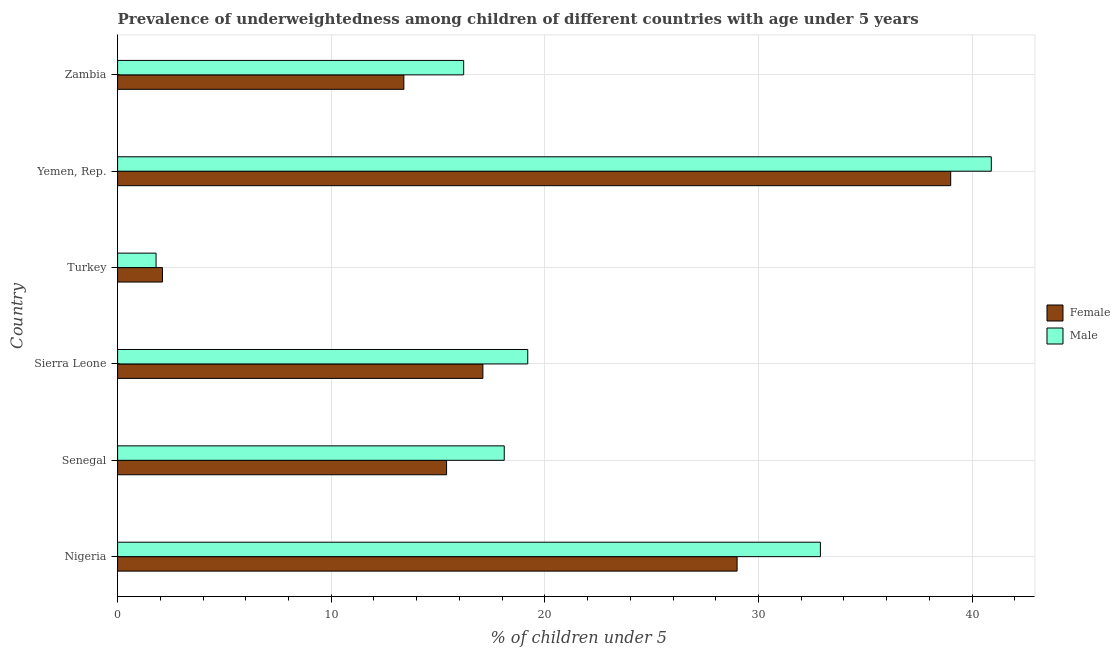Are the number of bars per tick equal to the number of legend labels?
Your answer should be very brief. Yes. How many bars are there on the 6th tick from the bottom?
Make the answer very short. 2. What is the label of the 6th group of bars from the top?
Give a very brief answer. Nigeria. In how many cases, is the number of bars for a given country not equal to the number of legend labels?
Keep it short and to the point. 0. Across all countries, what is the maximum percentage of underweighted female children?
Provide a short and direct response. 39. Across all countries, what is the minimum percentage of underweighted female children?
Your response must be concise. 2.1. In which country was the percentage of underweighted male children maximum?
Offer a terse response. Yemen, Rep. In which country was the percentage of underweighted female children minimum?
Provide a succinct answer. Turkey. What is the total percentage of underweighted female children in the graph?
Make the answer very short. 116. What is the difference between the percentage of underweighted female children in Sierra Leone and that in Zambia?
Your answer should be compact. 3.7. What is the difference between the percentage of underweighted male children in Zambia and the percentage of underweighted female children in Senegal?
Ensure brevity in your answer.  0.8. What is the average percentage of underweighted female children per country?
Keep it short and to the point. 19.33. What is the ratio of the percentage of underweighted female children in Turkey to that in Yemen, Rep.?
Offer a terse response. 0.05. Is the percentage of underweighted female children in Nigeria less than that in Yemen, Rep.?
Provide a succinct answer. Yes. Is the difference between the percentage of underweighted male children in Yemen, Rep. and Zambia greater than the difference between the percentage of underweighted female children in Yemen, Rep. and Zambia?
Offer a very short reply. No. What is the difference between the highest and the second highest percentage of underweighted male children?
Your response must be concise. 8. What is the difference between the highest and the lowest percentage of underweighted female children?
Provide a succinct answer. 36.9. Is the sum of the percentage of underweighted female children in Senegal and Turkey greater than the maximum percentage of underweighted male children across all countries?
Your answer should be compact. No. What does the 2nd bar from the top in Zambia represents?
Give a very brief answer. Female. What does the 2nd bar from the bottom in Senegal represents?
Your answer should be very brief. Male. How many countries are there in the graph?
Your answer should be very brief. 6. Are the values on the major ticks of X-axis written in scientific E-notation?
Provide a succinct answer. No. Does the graph contain grids?
Your answer should be very brief. Yes. Where does the legend appear in the graph?
Give a very brief answer. Center right. How many legend labels are there?
Offer a terse response. 2. How are the legend labels stacked?
Offer a terse response. Vertical. What is the title of the graph?
Offer a very short reply. Prevalence of underweightedness among children of different countries with age under 5 years. Does "Rural" appear as one of the legend labels in the graph?
Keep it short and to the point. No. What is the label or title of the X-axis?
Your answer should be very brief.  % of children under 5. What is the label or title of the Y-axis?
Make the answer very short. Country. What is the  % of children under 5 in Male in Nigeria?
Your answer should be compact. 32.9. What is the  % of children under 5 in Female in Senegal?
Your answer should be compact. 15.4. What is the  % of children under 5 of Male in Senegal?
Provide a short and direct response. 18.1. What is the  % of children under 5 of Female in Sierra Leone?
Your answer should be very brief. 17.1. What is the  % of children under 5 in Male in Sierra Leone?
Provide a succinct answer. 19.2. What is the  % of children under 5 of Female in Turkey?
Make the answer very short. 2.1. What is the  % of children under 5 in Male in Turkey?
Offer a very short reply. 1.8. What is the  % of children under 5 of Male in Yemen, Rep.?
Offer a terse response. 40.9. What is the  % of children under 5 in Female in Zambia?
Keep it short and to the point. 13.4. What is the  % of children under 5 in Male in Zambia?
Provide a succinct answer. 16.2. Across all countries, what is the maximum  % of children under 5 of Female?
Offer a very short reply. 39. Across all countries, what is the maximum  % of children under 5 of Male?
Offer a terse response. 40.9. Across all countries, what is the minimum  % of children under 5 in Female?
Provide a short and direct response. 2.1. Across all countries, what is the minimum  % of children under 5 of Male?
Provide a short and direct response. 1.8. What is the total  % of children under 5 in Female in the graph?
Give a very brief answer. 116. What is the total  % of children under 5 in Male in the graph?
Offer a terse response. 129.1. What is the difference between the  % of children under 5 of Male in Nigeria and that in Senegal?
Offer a terse response. 14.8. What is the difference between the  % of children under 5 of Female in Nigeria and that in Sierra Leone?
Provide a succinct answer. 11.9. What is the difference between the  % of children under 5 in Male in Nigeria and that in Sierra Leone?
Your answer should be compact. 13.7. What is the difference between the  % of children under 5 of Female in Nigeria and that in Turkey?
Ensure brevity in your answer.  26.9. What is the difference between the  % of children under 5 in Male in Nigeria and that in Turkey?
Your response must be concise. 31.1. What is the difference between the  % of children under 5 in Female in Nigeria and that in Zambia?
Your response must be concise. 15.6. What is the difference between the  % of children under 5 in Male in Nigeria and that in Zambia?
Your response must be concise. 16.7. What is the difference between the  % of children under 5 of Male in Senegal and that in Sierra Leone?
Provide a short and direct response. -1.1. What is the difference between the  % of children under 5 in Male in Senegal and that in Turkey?
Your answer should be compact. 16.3. What is the difference between the  % of children under 5 in Female in Senegal and that in Yemen, Rep.?
Your answer should be compact. -23.6. What is the difference between the  % of children under 5 of Male in Senegal and that in Yemen, Rep.?
Your response must be concise. -22.8. What is the difference between the  % of children under 5 of Female in Senegal and that in Zambia?
Provide a succinct answer. 2. What is the difference between the  % of children under 5 of Male in Senegal and that in Zambia?
Your answer should be very brief. 1.9. What is the difference between the  % of children under 5 in Female in Sierra Leone and that in Yemen, Rep.?
Offer a very short reply. -21.9. What is the difference between the  % of children under 5 in Male in Sierra Leone and that in Yemen, Rep.?
Your answer should be compact. -21.7. What is the difference between the  % of children under 5 of Male in Sierra Leone and that in Zambia?
Your response must be concise. 3. What is the difference between the  % of children under 5 of Female in Turkey and that in Yemen, Rep.?
Keep it short and to the point. -36.9. What is the difference between the  % of children under 5 in Male in Turkey and that in Yemen, Rep.?
Your answer should be very brief. -39.1. What is the difference between the  % of children under 5 in Male in Turkey and that in Zambia?
Your response must be concise. -14.4. What is the difference between the  % of children under 5 in Female in Yemen, Rep. and that in Zambia?
Give a very brief answer. 25.6. What is the difference between the  % of children under 5 of Male in Yemen, Rep. and that in Zambia?
Provide a short and direct response. 24.7. What is the difference between the  % of children under 5 of Female in Nigeria and the  % of children under 5 of Male in Turkey?
Your answer should be compact. 27.2. What is the difference between the  % of children under 5 of Female in Nigeria and the  % of children under 5 of Male in Zambia?
Provide a short and direct response. 12.8. What is the difference between the  % of children under 5 in Female in Senegal and the  % of children under 5 in Male in Turkey?
Your answer should be very brief. 13.6. What is the difference between the  % of children under 5 of Female in Senegal and the  % of children under 5 of Male in Yemen, Rep.?
Your answer should be compact. -25.5. What is the difference between the  % of children under 5 in Female in Sierra Leone and the  % of children under 5 in Male in Turkey?
Keep it short and to the point. 15.3. What is the difference between the  % of children under 5 of Female in Sierra Leone and the  % of children under 5 of Male in Yemen, Rep.?
Give a very brief answer. -23.8. What is the difference between the  % of children under 5 of Female in Sierra Leone and the  % of children under 5 of Male in Zambia?
Your answer should be compact. 0.9. What is the difference between the  % of children under 5 in Female in Turkey and the  % of children under 5 in Male in Yemen, Rep.?
Ensure brevity in your answer.  -38.8. What is the difference between the  % of children under 5 of Female in Turkey and the  % of children under 5 of Male in Zambia?
Your response must be concise. -14.1. What is the difference between the  % of children under 5 in Female in Yemen, Rep. and the  % of children under 5 in Male in Zambia?
Provide a succinct answer. 22.8. What is the average  % of children under 5 in Female per country?
Your answer should be compact. 19.33. What is the average  % of children under 5 of Male per country?
Your answer should be very brief. 21.52. What is the difference between the  % of children under 5 of Female and  % of children under 5 of Male in Nigeria?
Keep it short and to the point. -3.9. What is the difference between the  % of children under 5 in Female and  % of children under 5 in Male in Senegal?
Keep it short and to the point. -2.7. What is the difference between the  % of children under 5 in Female and  % of children under 5 in Male in Sierra Leone?
Your answer should be compact. -2.1. What is the difference between the  % of children under 5 in Female and  % of children under 5 in Male in Yemen, Rep.?
Your answer should be very brief. -1.9. What is the ratio of the  % of children under 5 of Female in Nigeria to that in Senegal?
Provide a succinct answer. 1.88. What is the ratio of the  % of children under 5 in Male in Nigeria to that in Senegal?
Give a very brief answer. 1.82. What is the ratio of the  % of children under 5 of Female in Nigeria to that in Sierra Leone?
Your answer should be compact. 1.7. What is the ratio of the  % of children under 5 of Male in Nigeria to that in Sierra Leone?
Offer a very short reply. 1.71. What is the ratio of the  % of children under 5 of Female in Nigeria to that in Turkey?
Your answer should be compact. 13.81. What is the ratio of the  % of children under 5 in Male in Nigeria to that in Turkey?
Provide a succinct answer. 18.28. What is the ratio of the  % of children under 5 of Female in Nigeria to that in Yemen, Rep.?
Provide a succinct answer. 0.74. What is the ratio of the  % of children under 5 of Male in Nigeria to that in Yemen, Rep.?
Offer a very short reply. 0.8. What is the ratio of the  % of children under 5 of Female in Nigeria to that in Zambia?
Make the answer very short. 2.16. What is the ratio of the  % of children under 5 in Male in Nigeria to that in Zambia?
Ensure brevity in your answer.  2.03. What is the ratio of the  % of children under 5 in Female in Senegal to that in Sierra Leone?
Provide a succinct answer. 0.9. What is the ratio of the  % of children under 5 of Male in Senegal to that in Sierra Leone?
Your answer should be very brief. 0.94. What is the ratio of the  % of children under 5 of Female in Senegal to that in Turkey?
Your answer should be very brief. 7.33. What is the ratio of the  % of children under 5 of Male in Senegal to that in Turkey?
Your response must be concise. 10.06. What is the ratio of the  % of children under 5 in Female in Senegal to that in Yemen, Rep.?
Make the answer very short. 0.39. What is the ratio of the  % of children under 5 of Male in Senegal to that in Yemen, Rep.?
Your response must be concise. 0.44. What is the ratio of the  % of children under 5 of Female in Senegal to that in Zambia?
Your response must be concise. 1.15. What is the ratio of the  % of children under 5 of Male in Senegal to that in Zambia?
Give a very brief answer. 1.12. What is the ratio of the  % of children under 5 of Female in Sierra Leone to that in Turkey?
Keep it short and to the point. 8.14. What is the ratio of the  % of children under 5 of Male in Sierra Leone to that in Turkey?
Give a very brief answer. 10.67. What is the ratio of the  % of children under 5 in Female in Sierra Leone to that in Yemen, Rep.?
Ensure brevity in your answer.  0.44. What is the ratio of the  % of children under 5 of Male in Sierra Leone to that in Yemen, Rep.?
Ensure brevity in your answer.  0.47. What is the ratio of the  % of children under 5 of Female in Sierra Leone to that in Zambia?
Ensure brevity in your answer.  1.28. What is the ratio of the  % of children under 5 of Male in Sierra Leone to that in Zambia?
Ensure brevity in your answer.  1.19. What is the ratio of the  % of children under 5 in Female in Turkey to that in Yemen, Rep.?
Keep it short and to the point. 0.05. What is the ratio of the  % of children under 5 in Male in Turkey to that in Yemen, Rep.?
Your response must be concise. 0.04. What is the ratio of the  % of children under 5 of Female in Turkey to that in Zambia?
Your answer should be compact. 0.16. What is the ratio of the  % of children under 5 of Female in Yemen, Rep. to that in Zambia?
Offer a terse response. 2.91. What is the ratio of the  % of children under 5 of Male in Yemen, Rep. to that in Zambia?
Ensure brevity in your answer.  2.52. What is the difference between the highest and the second highest  % of children under 5 of Female?
Your response must be concise. 10. What is the difference between the highest and the second highest  % of children under 5 of Male?
Keep it short and to the point. 8. What is the difference between the highest and the lowest  % of children under 5 in Female?
Give a very brief answer. 36.9. What is the difference between the highest and the lowest  % of children under 5 in Male?
Make the answer very short. 39.1. 